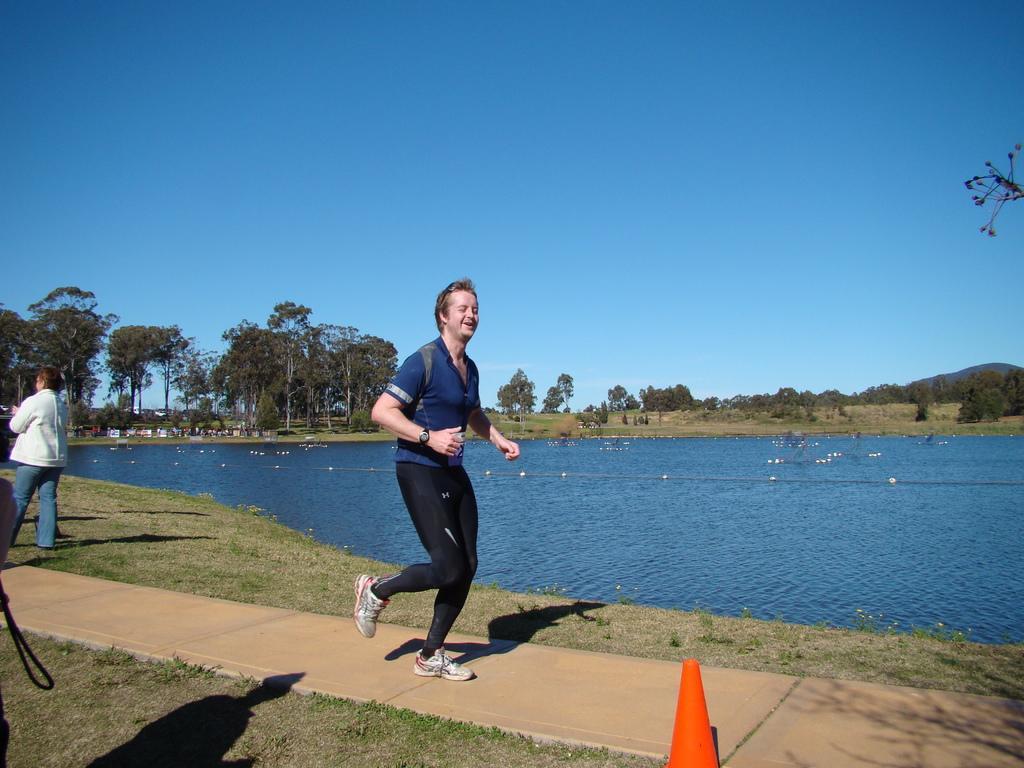Describe this image in one or two sentences. In the center of the image we can see a man running. At the bottom we can see a traffic cone. On the left there is a person. In the background there is a river and we can see trees. There is a hill. At the top there is sky. 